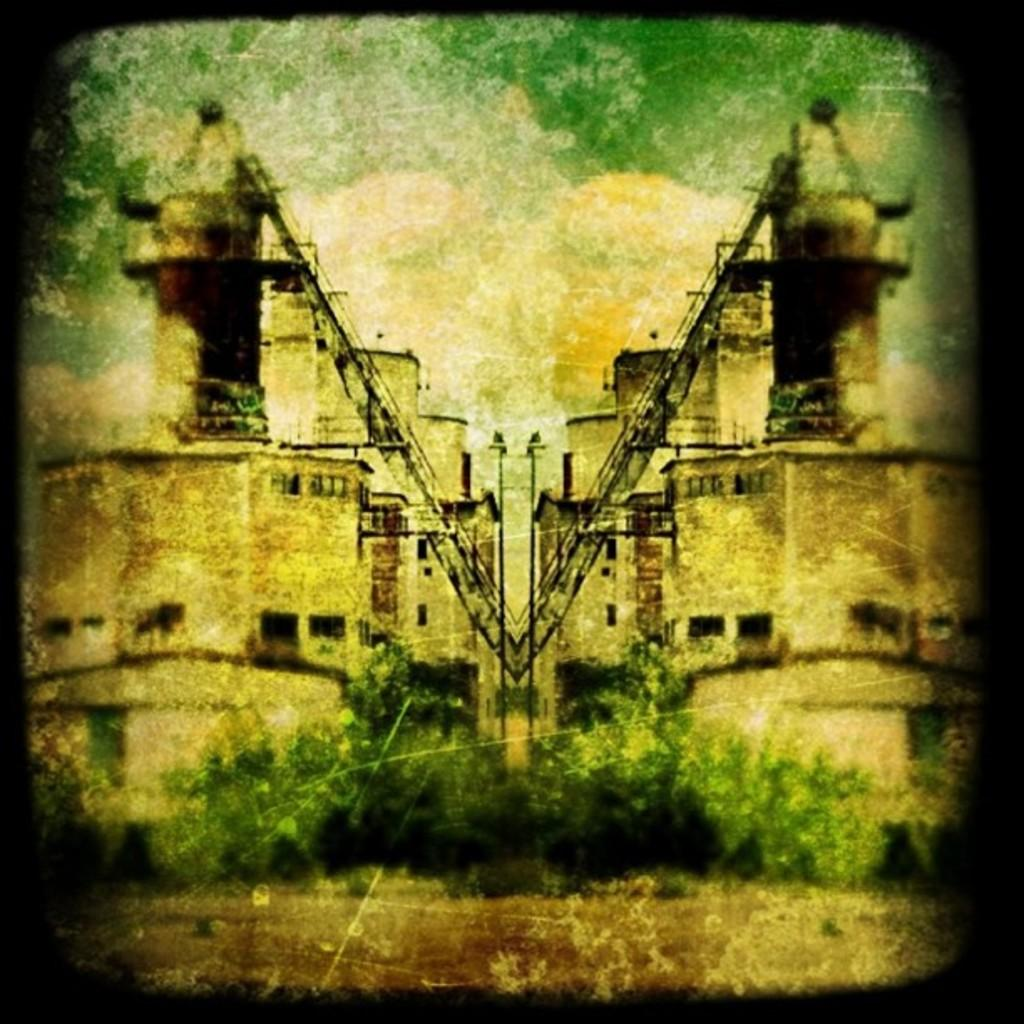What type of image is depicted in the photograph? The image contains an old photograph. What can be seen on the ground in the photograph? The ground is visible in the photograph. What type of vegetation is present in the photograph? There are green trees in the photograph. What type of structures can be seen in the photograph? There are buildings in the photograph. What part of the natural environment is visible in the photograph? The sky is visible in the photograph. What type of advice is being given in the photograph? There is no advice being given in the photograph; it is an image of an old photograph containing a scene with green trees, buildings, and the sky. What type of net can be seen in the photograph? There is no net present in the photograph. 